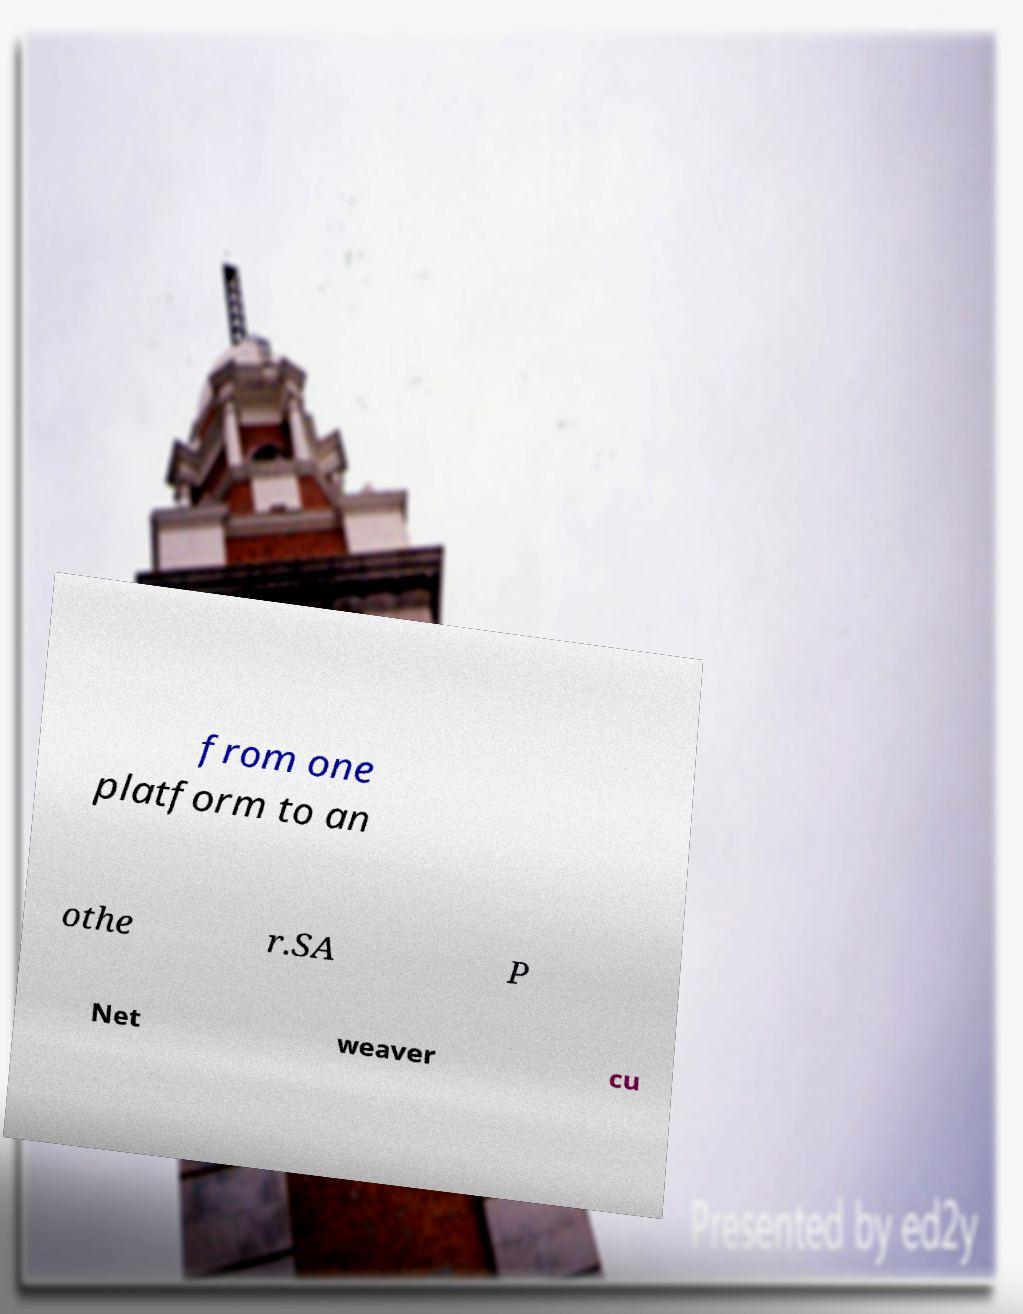Can you accurately transcribe the text from the provided image for me? from one platform to an othe r.SA P Net weaver cu 